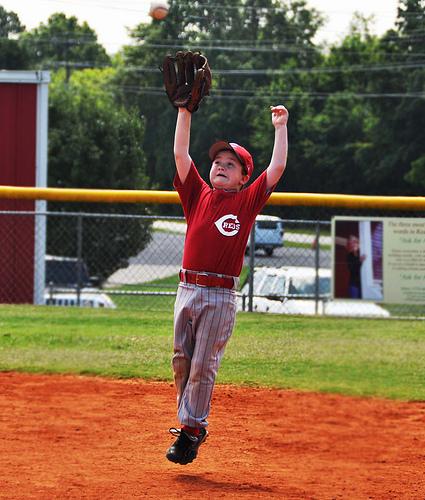Is the boy left or right handed?
Be succinct. Left. Why does the young man's face look that way?
Give a very brief answer. Excitement. What color is the young man' shirt?
Answer briefly. Red. 